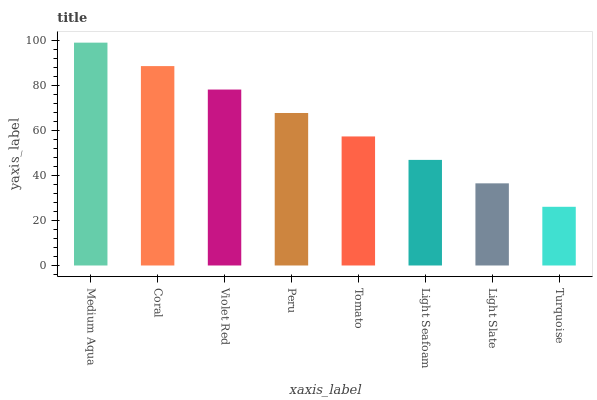Is Turquoise the minimum?
Answer yes or no. Yes. Is Medium Aqua the maximum?
Answer yes or no. Yes. Is Coral the minimum?
Answer yes or no. No. Is Coral the maximum?
Answer yes or no. No. Is Medium Aqua greater than Coral?
Answer yes or no. Yes. Is Coral less than Medium Aqua?
Answer yes or no. Yes. Is Coral greater than Medium Aqua?
Answer yes or no. No. Is Medium Aqua less than Coral?
Answer yes or no. No. Is Peru the high median?
Answer yes or no. Yes. Is Tomato the low median?
Answer yes or no. Yes. Is Tomato the high median?
Answer yes or no. No. Is Light Slate the low median?
Answer yes or no. No. 